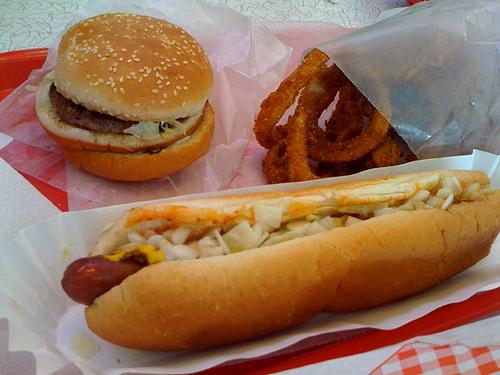Where could you get this food? restaurant 